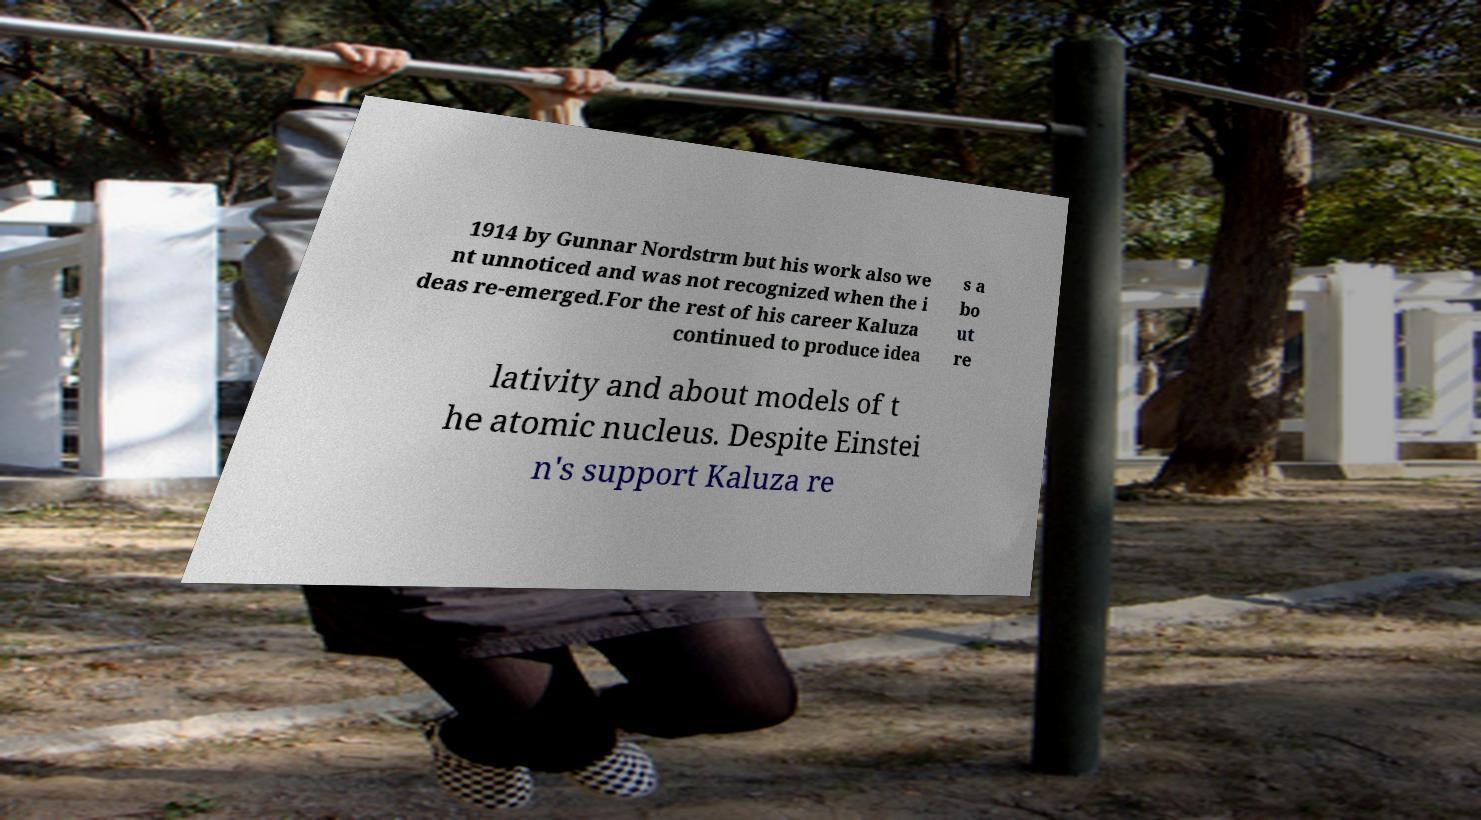For documentation purposes, I need the text within this image transcribed. Could you provide that? 1914 by Gunnar Nordstrm but his work also we nt unnoticed and was not recognized when the i deas re-emerged.For the rest of his career Kaluza continued to produce idea s a bo ut re lativity and about models of t he atomic nucleus. Despite Einstei n's support Kaluza re 